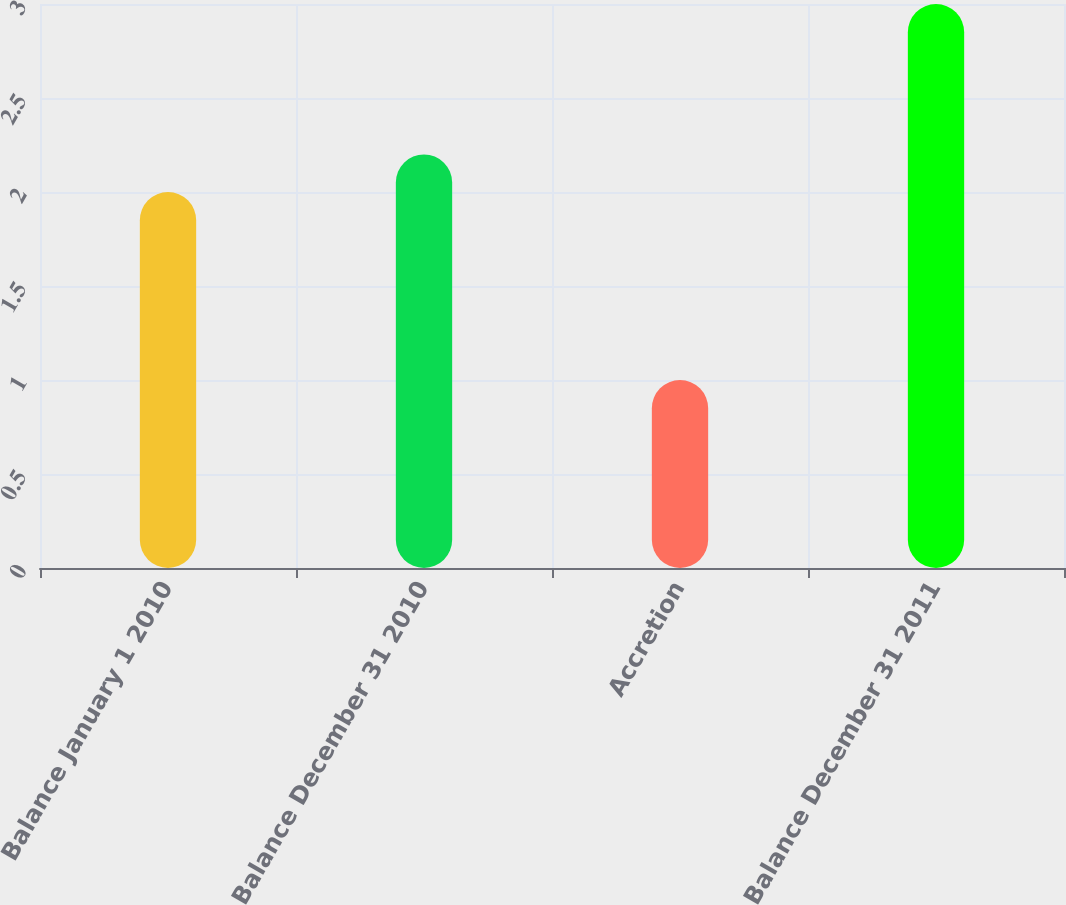<chart> <loc_0><loc_0><loc_500><loc_500><bar_chart><fcel>Balance January 1 2010<fcel>Balance December 31 2010<fcel>Accretion<fcel>Balance December 31 2011<nl><fcel>2<fcel>2.2<fcel>1<fcel>3<nl></chart> 